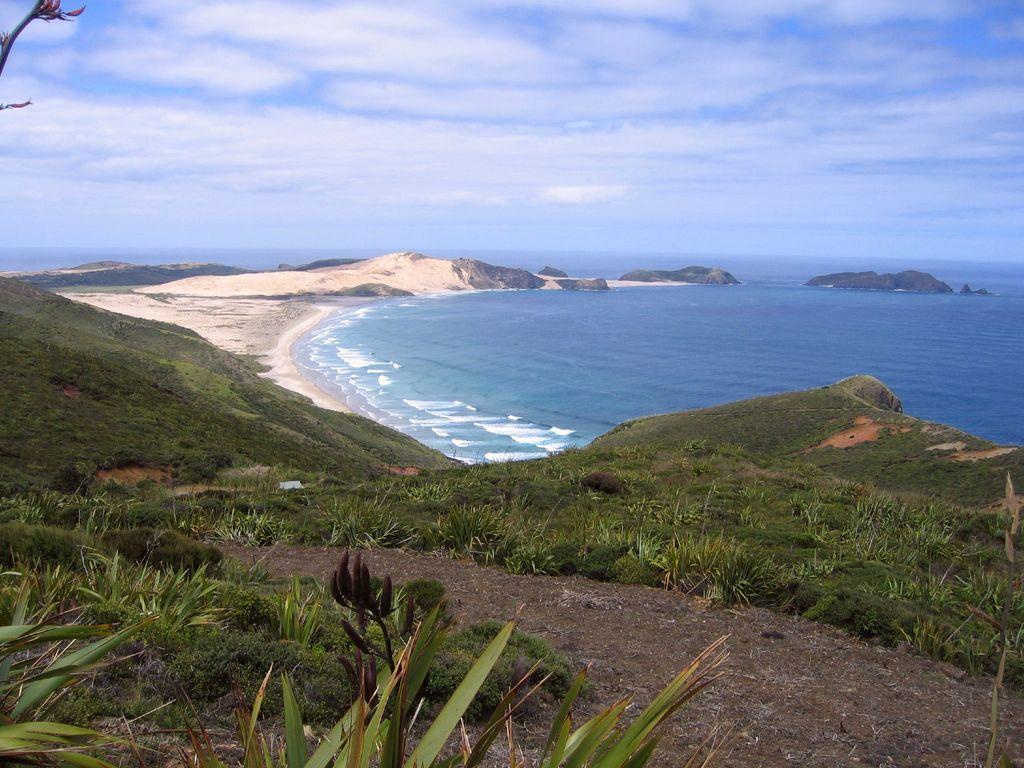How would you summarize this image in a sentence or two? In this image in the center there is a beach and at the bottom there are some plants grass and sand, in the background there are some mountains. On the top of the image there is sky. 